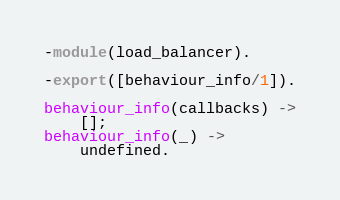Convert code to text. <code><loc_0><loc_0><loc_500><loc_500><_Erlang_>-module(load_balancer).

-export([behaviour_info/1]).

behaviour_info(callbacks) ->
    [];
behaviour_info(_) ->
    undefined.
</code> 